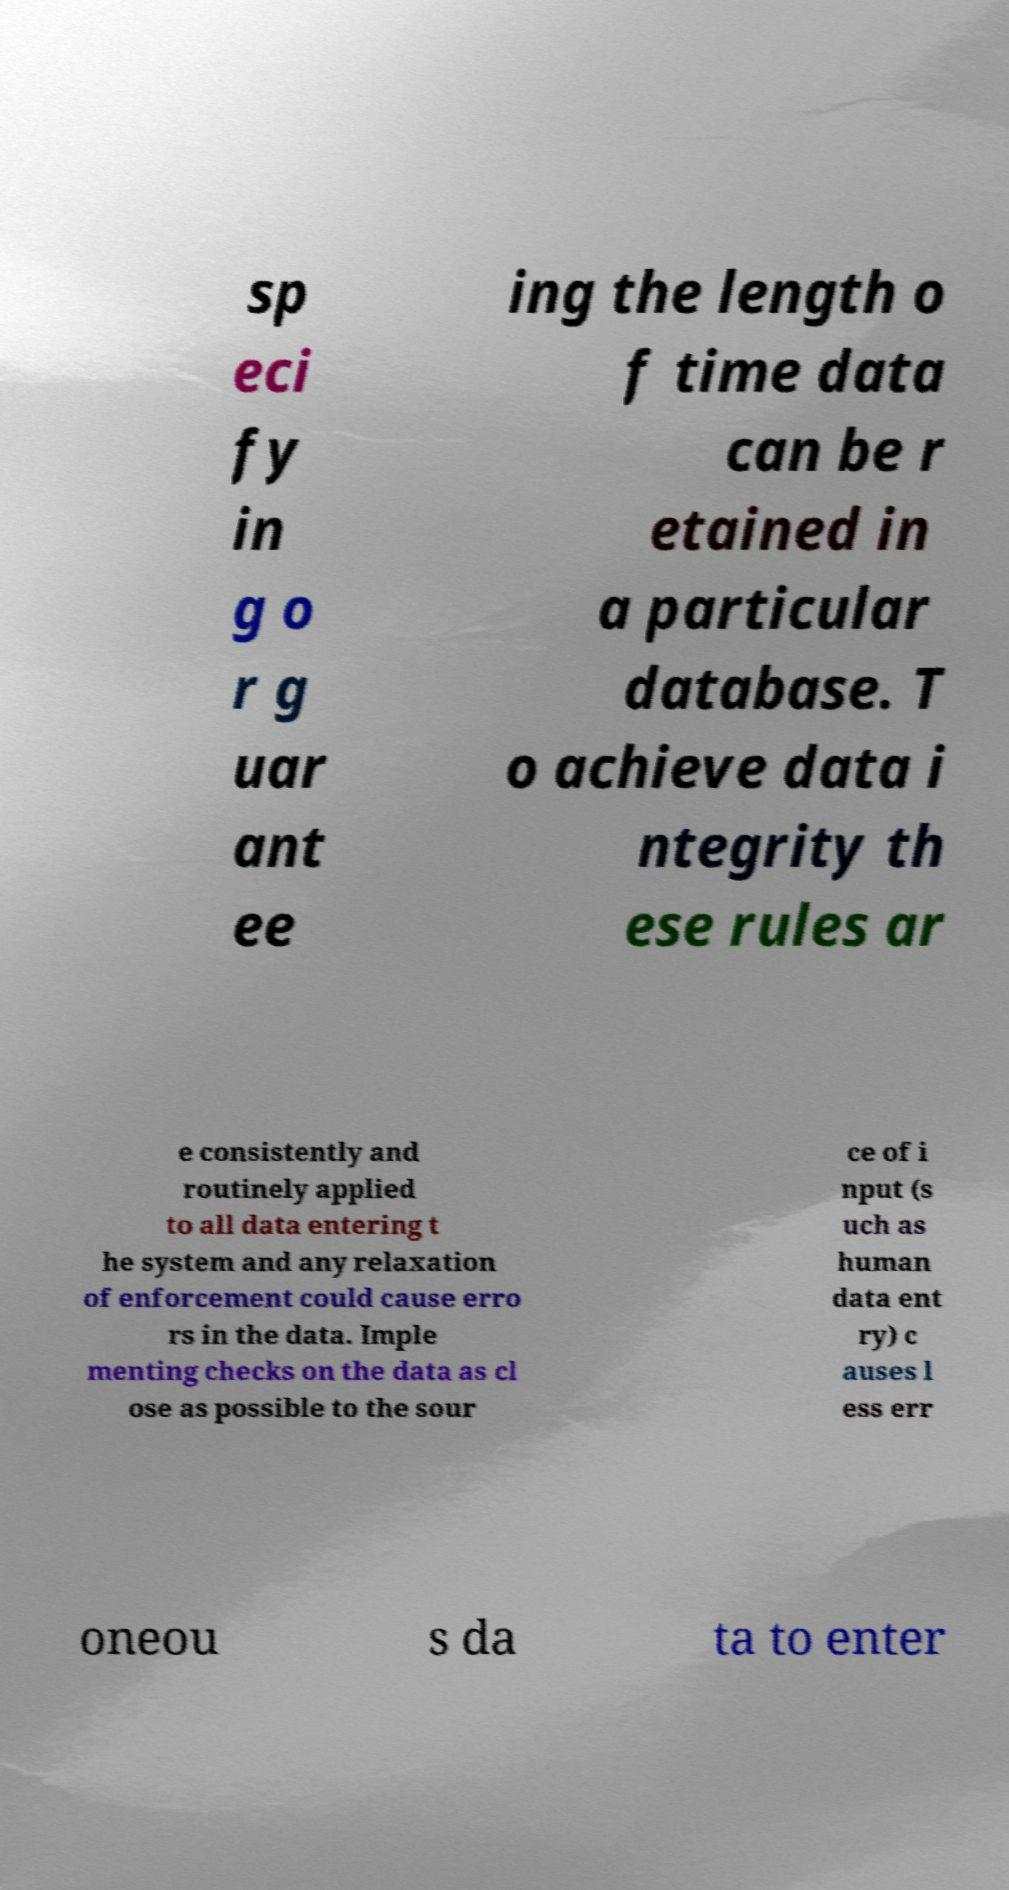Can you read and provide the text displayed in the image?This photo seems to have some interesting text. Can you extract and type it out for me? sp eci fy in g o r g uar ant ee ing the length o f time data can be r etained in a particular database. T o achieve data i ntegrity th ese rules ar e consistently and routinely applied to all data entering t he system and any relaxation of enforcement could cause erro rs in the data. Imple menting checks on the data as cl ose as possible to the sour ce of i nput (s uch as human data ent ry) c auses l ess err oneou s da ta to enter 